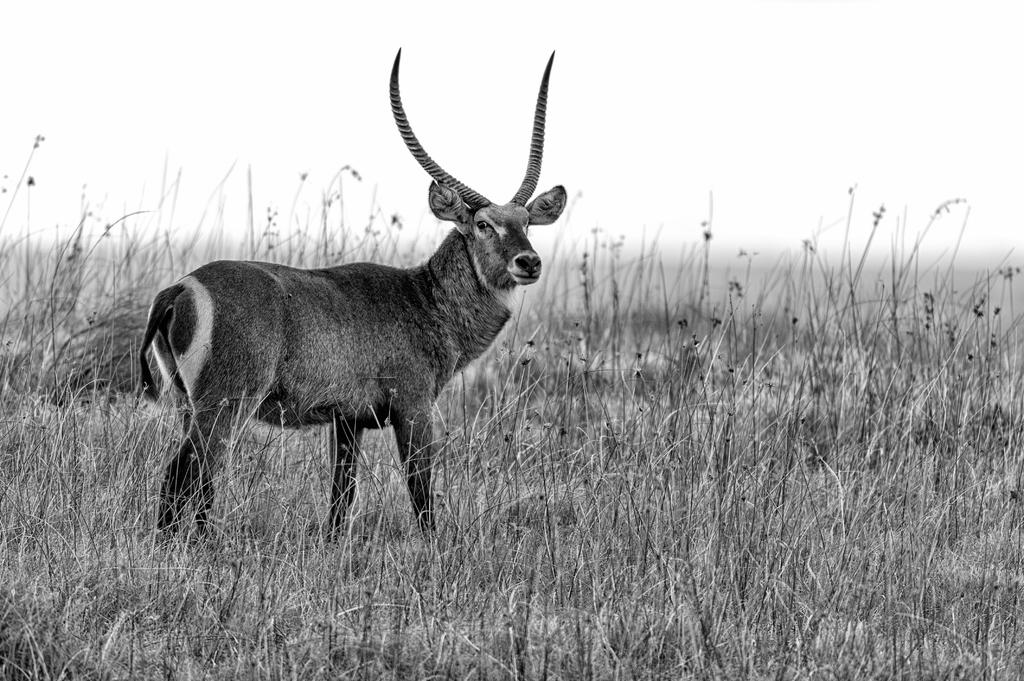What animal can be seen in the field in the image? There is a deer in the field. What type of vegetation is present around the deer? There are plants around the deer. What type of fruit is the deer coughing up in the image? There is no fruit or coughing depicted in the image; it features a deer in a field surrounded by plants. 